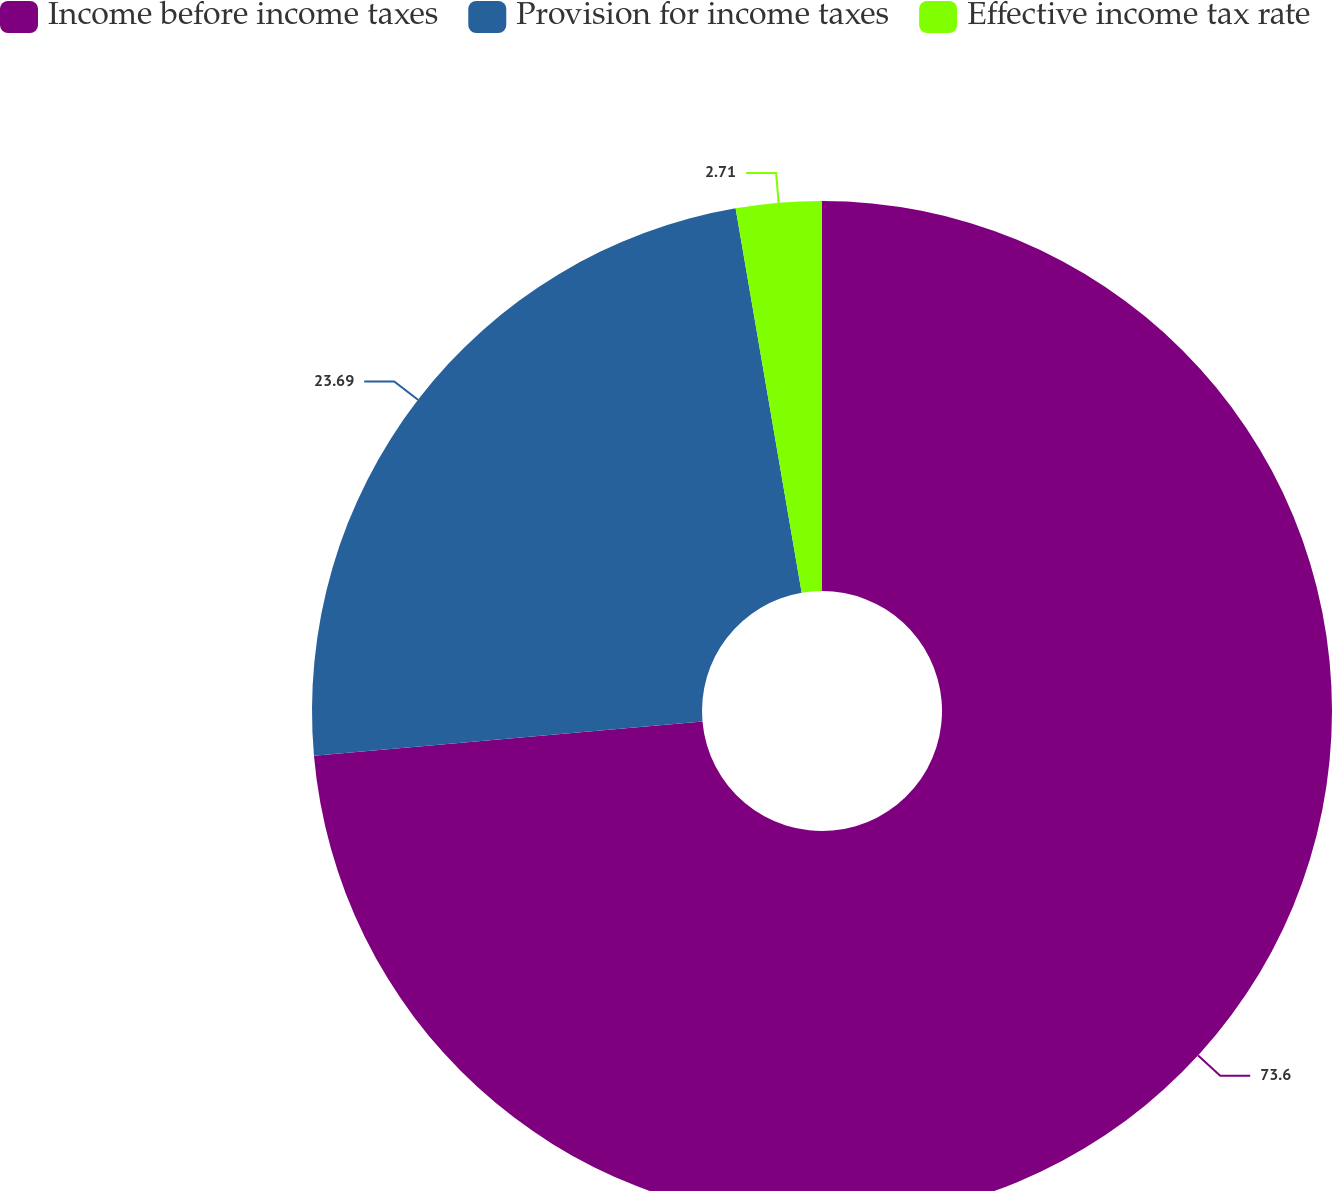<chart> <loc_0><loc_0><loc_500><loc_500><pie_chart><fcel>Income before income taxes<fcel>Provision for income taxes<fcel>Effective income tax rate<nl><fcel>73.61%<fcel>23.69%<fcel>2.71%<nl></chart> 